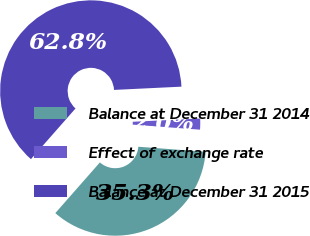Convert chart. <chart><loc_0><loc_0><loc_500><loc_500><pie_chart><fcel>Balance at December 31 2014<fcel>Effect of exchange rate<fcel>Balance at December 31 2015<nl><fcel>35.29%<fcel>1.96%<fcel>62.75%<nl></chart> 